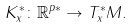Convert formula to latex. <formula><loc_0><loc_0><loc_500><loc_500>K _ { x } ^ { * } \colon \mathbb { R } ^ { p * } \to T _ { x } ^ { * } M .</formula> 